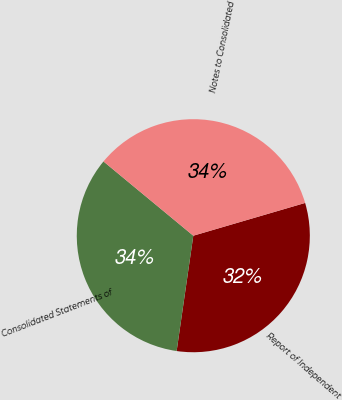Convert chart to OTSL. <chart><loc_0><loc_0><loc_500><loc_500><pie_chart><fcel>Report of Independent<fcel>Consolidated Statements of<fcel>Notes to Consolidated<nl><fcel>31.82%<fcel>33.71%<fcel>34.47%<nl></chart> 